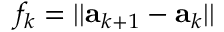Convert formula to latex. <formula><loc_0><loc_0><loc_500><loc_500>f _ { k } = | | { a } _ { k + 1 } - { a } _ { k } | |</formula> 